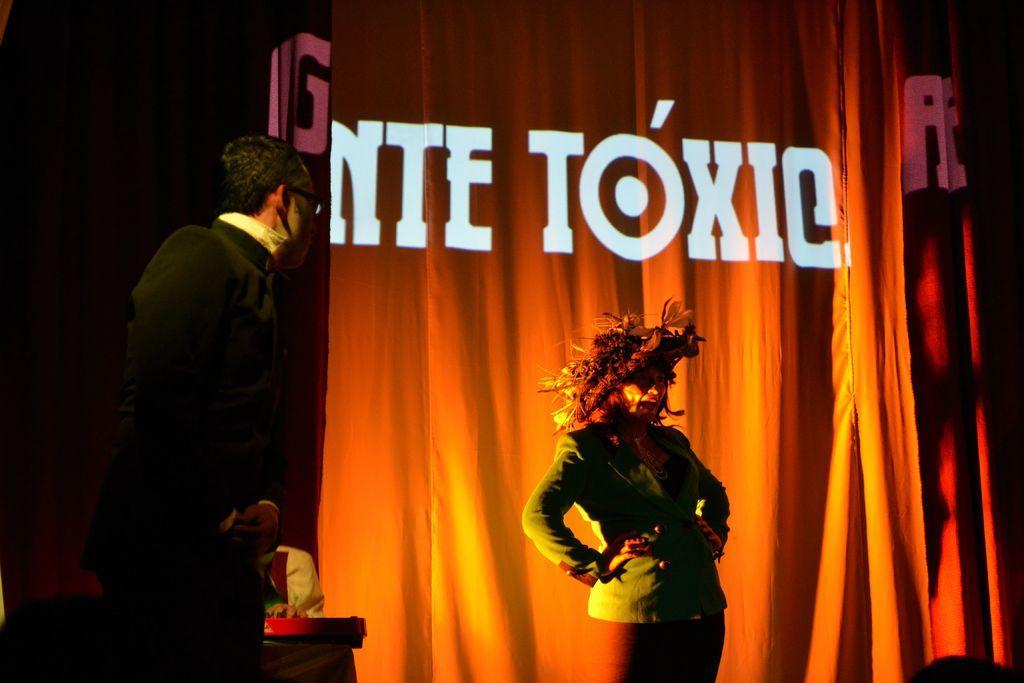Can you describe this image briefly? This picture shows a man and a woman standing on the dais and she wore a cap on the head and we see a cloth on the back, Displaying text on it. 